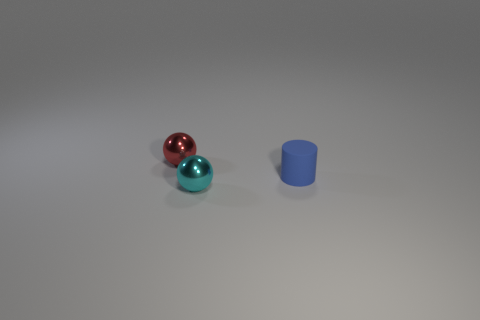What size is the cyan ball?
Offer a terse response. Small. There is a sphere to the right of the tiny object behind the blue thing; what size is it?
Give a very brief answer. Small. There is a object that is on the right side of the small cyan ball; what is its size?
Provide a short and direct response. Small. What number of rubber objects are either small cyan things or large brown blocks?
Your answer should be compact. 0. How many blue objects are metallic things or rubber cylinders?
Your answer should be very brief. 1. Are the small cyan sphere and the tiny cylinder made of the same material?
Offer a terse response. No. Are there an equal number of small objects that are left of the cyan shiny ball and tiny red metallic balls behind the tiny blue object?
Ensure brevity in your answer.  Yes. What is the shape of the small shiny object to the right of the tiny shiny object that is on the left side of the small metal thing in front of the small red metal thing?
Offer a very short reply. Sphere. Is the number of spheres that are behind the blue cylinder greater than the number of purple matte things?
Ensure brevity in your answer.  Yes. Does the tiny metallic object that is in front of the tiny matte object have the same shape as the red shiny thing?
Give a very brief answer. Yes. 